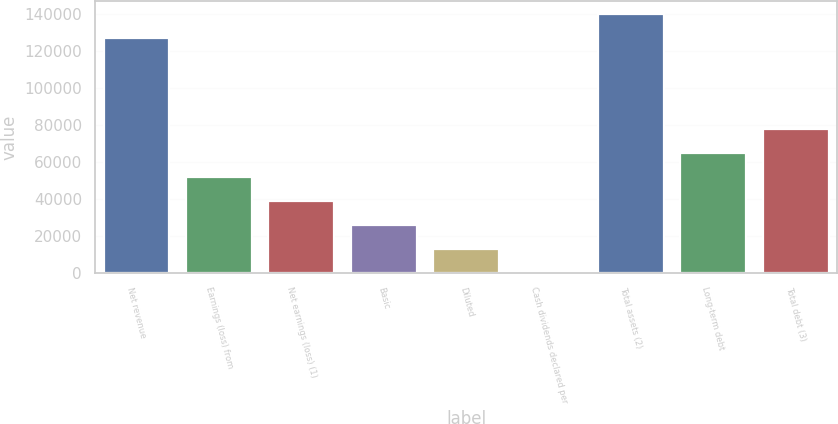Convert chart to OTSL. <chart><loc_0><loc_0><loc_500><loc_500><bar_chart><fcel>Net revenue<fcel>Earnings (loss) from<fcel>Net earnings (loss) (1)<fcel>Basic<fcel>Diluted<fcel>Cash dividends declared per<fcel>Total assets (2)<fcel>Long-term debt<fcel>Total debt (3)<nl><fcel>127245<fcel>51807<fcel>38855.4<fcel>25903.7<fcel>12952.1<fcel>0.4<fcel>140197<fcel>64758.7<fcel>77710.4<nl></chart> 